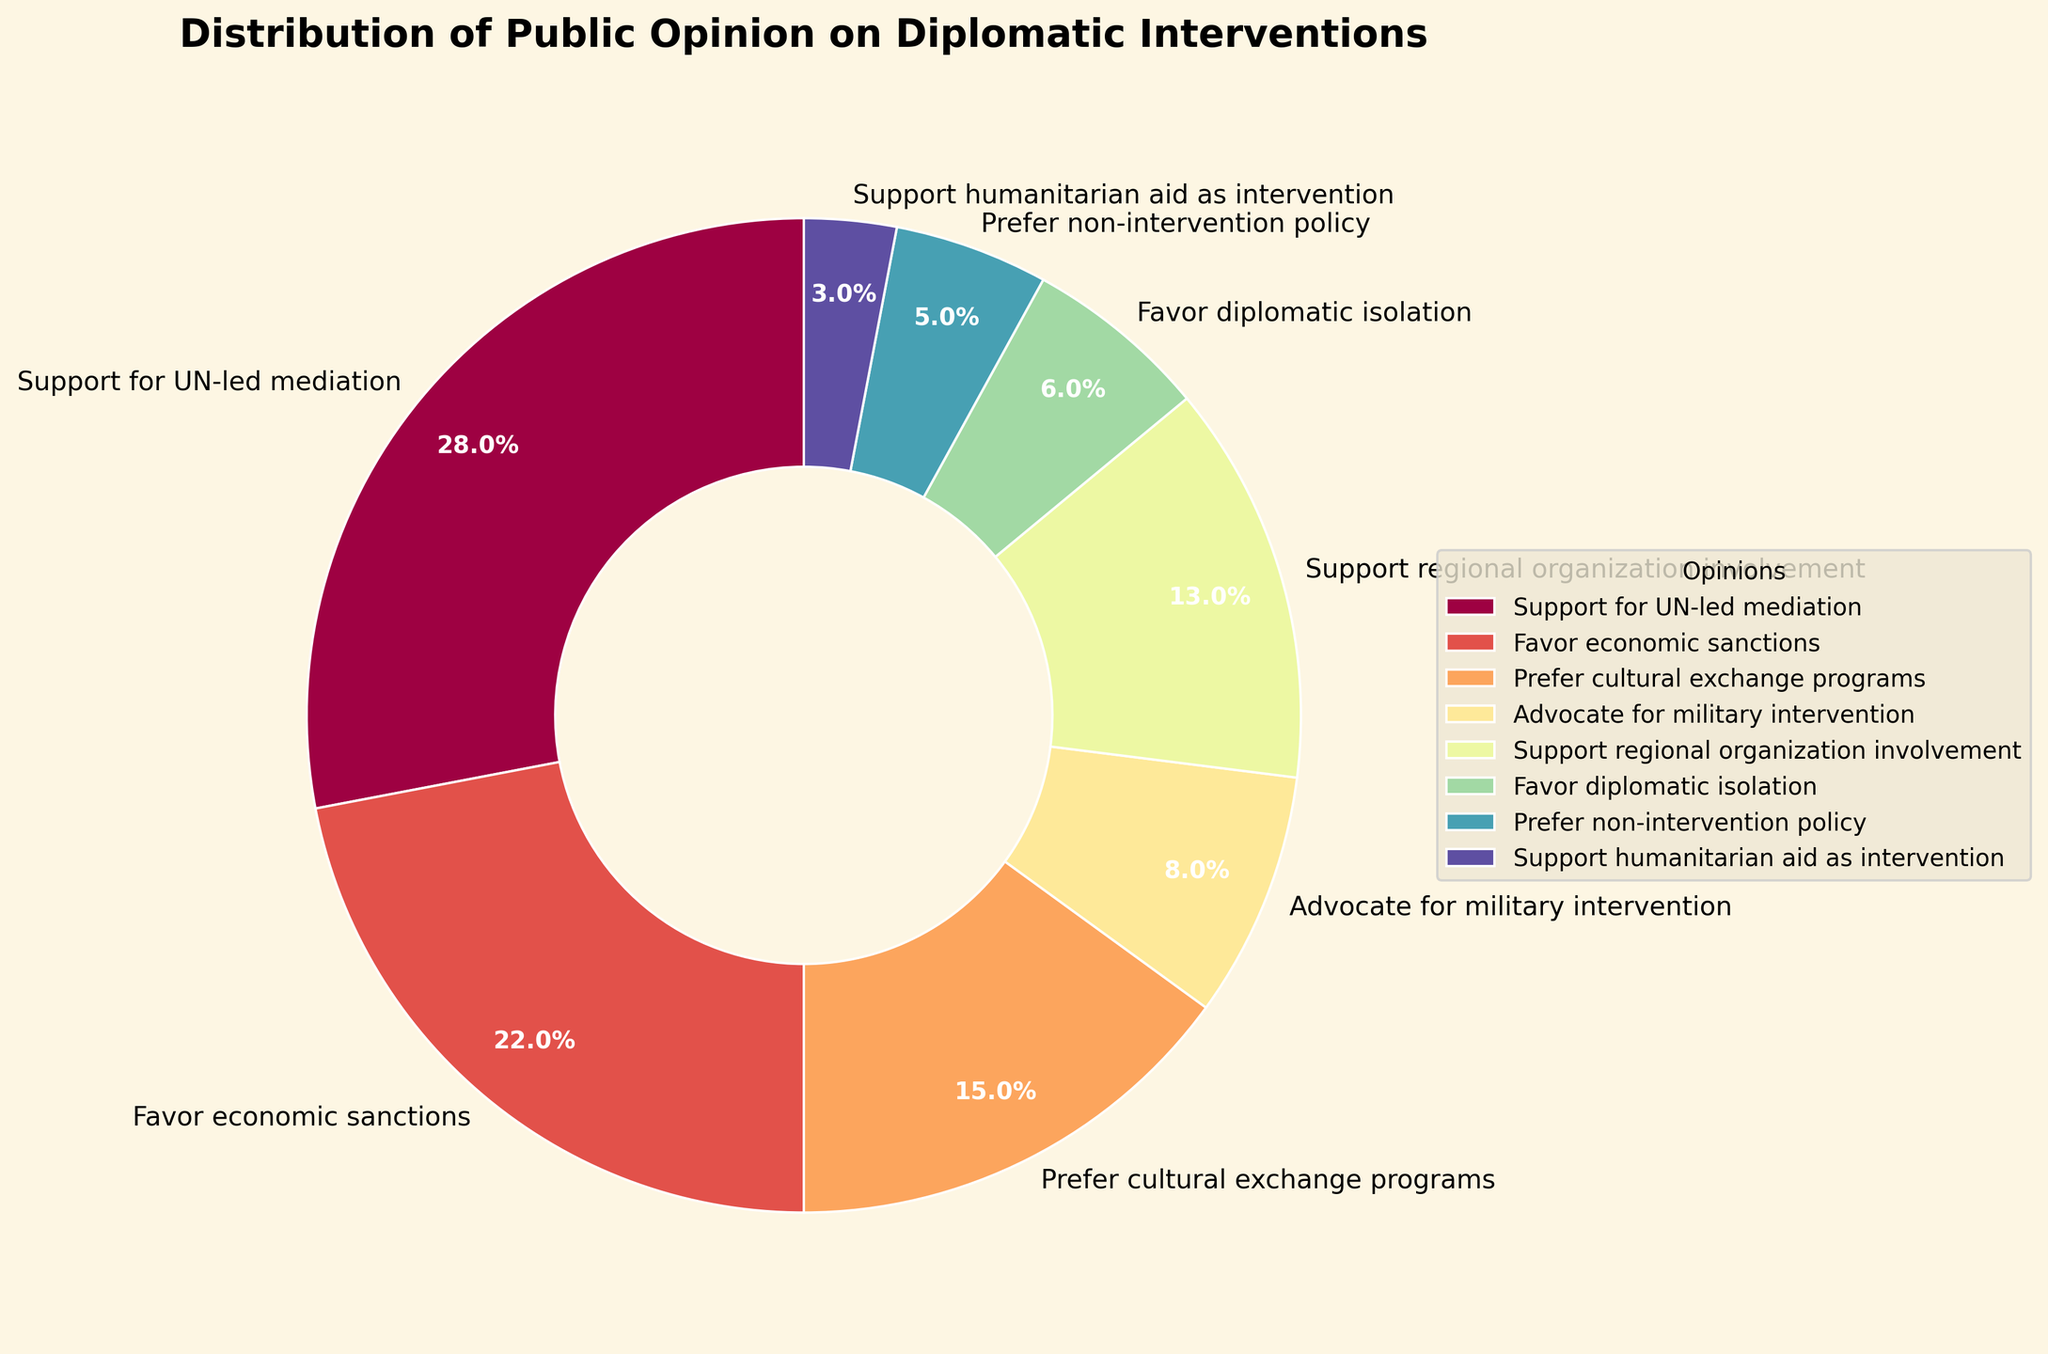which type of intervention had the highest level of public support? The figure indicates the distribution of public opinion. The largest section of the pie chart represents "Support for UN-led mediation" with 28%.
Answer: Support for UN-led mediation Which type of intervention had the lowest level of public support? The smallest section of the pie chart represents "Support humanitarian aid as intervention" with 3%.
Answer: Support humanitarian aid as intervention How much more percentage does "Support for UN-led mediation" have compared to "Advocate for military intervention"? The percentage for "Support for UN-led mediation" is 28% and for "Advocate for military intervention" is 8%. So, the difference is 28% - 8% = 20%.
Answer: 20% What is the combined percentage of people who prefer non-intervention policies (non-intervention policy + diplomatic isolation)? The percentages for "Prefer non-intervention policy" and "Favor diplomatic isolation" are 5% and 6% respectively. So, the combined percentage is 5% + 6% = 11%.
Answer: 11% Which two categories have almost similar levels of public opinion percentages? The figure shows that "Favor economic sanctions" and "Support regional organization involvement" have close percentages, with 22% and 13% respectively. Comparing other pairs, these two are more similar than others.
Answer: Favor economic sanctions and Support regional organization involvement What's the percentage difference between "Favor economic sanctions" and "Prefer cultural exchange programs"? The percentage for "Favor economic sanctions" is 22% and for "Prefer cultural exchange programs" is 15%. So, the difference is 22% - 15% = 7%.
Answer: 7% What is the total percentage of people who either support economic sanctions or prefer cultural exchange programs? The percentages for "Favor economic sanctions" and "Prefer cultural exchange programs" are 22% and 15% respectively. So, the combined percentage is 22% + 15% = 37%.
Answer: 37% If you add together the percentages of those who support UN-led mediation, favor economic sanctions, and prefer cultural exchange programs, what percentage do you get? The percentages for "Support for UN-led mediation", "Favor economic sanctions", and "Prefer cultural exchange programs" are 28%, 22%, and 15% respectively. Adding them together: 28% + 22% + 15% = 65%.
Answer: 65% 